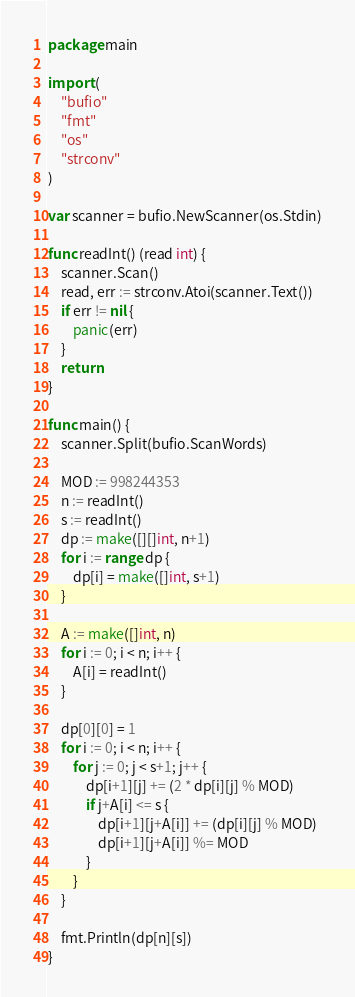<code> <loc_0><loc_0><loc_500><loc_500><_Go_>package main

import (
	"bufio"
	"fmt"
	"os"
	"strconv"
)

var scanner = bufio.NewScanner(os.Stdin)

func readInt() (read int) {
	scanner.Scan()
	read, err := strconv.Atoi(scanner.Text())
	if err != nil {
		panic(err)
	}
	return
}

func main() {
	scanner.Split(bufio.ScanWords)

	MOD := 998244353
	n := readInt()
	s := readInt()
	dp := make([][]int, n+1)
	for i := range dp {
		dp[i] = make([]int, s+1)
	}

	A := make([]int, n)
	for i := 0; i < n; i++ {
		A[i] = readInt()
	}

	dp[0][0] = 1
	for i := 0; i < n; i++ {
		for j := 0; j < s+1; j++ {
			dp[i+1][j] += (2 * dp[i][j] % MOD)
			if j+A[i] <= s {
				dp[i+1][j+A[i]] += (dp[i][j] % MOD)
				dp[i+1][j+A[i]] %= MOD
			}
		}
	}

	fmt.Println(dp[n][s])
}</code> 